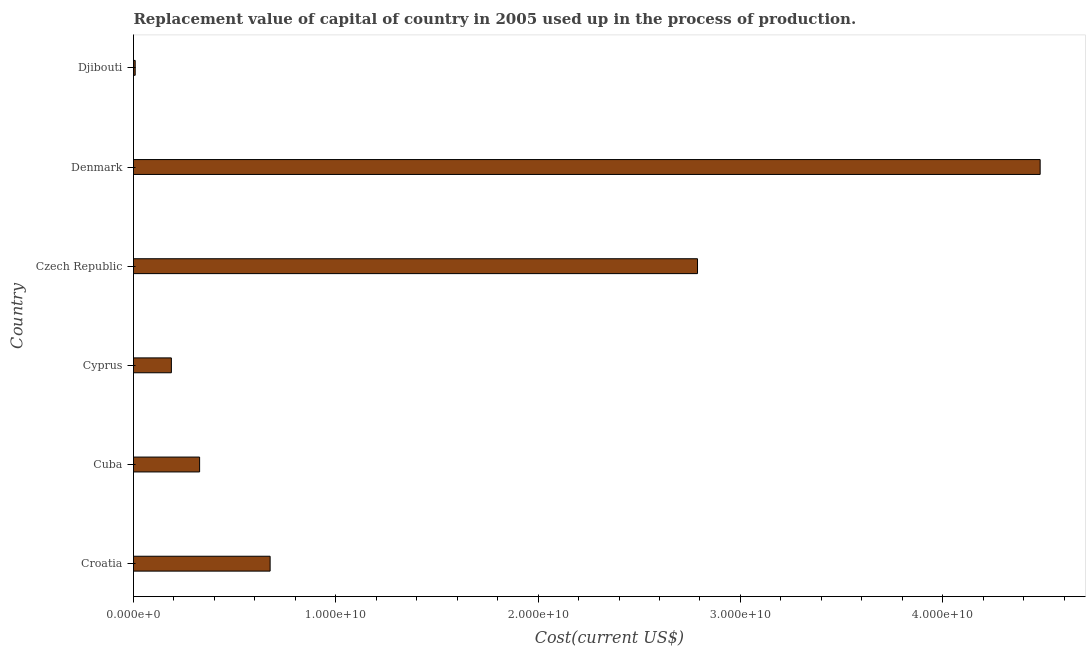What is the title of the graph?
Offer a very short reply. Replacement value of capital of country in 2005 used up in the process of production. What is the label or title of the X-axis?
Make the answer very short. Cost(current US$). What is the label or title of the Y-axis?
Provide a short and direct response. Country. What is the consumption of fixed capital in Denmark?
Ensure brevity in your answer.  4.48e+1. Across all countries, what is the maximum consumption of fixed capital?
Offer a very short reply. 4.48e+1. Across all countries, what is the minimum consumption of fixed capital?
Provide a short and direct response. 8.33e+07. In which country was the consumption of fixed capital minimum?
Give a very brief answer. Djibouti. What is the sum of the consumption of fixed capital?
Provide a succinct answer. 8.47e+1. What is the difference between the consumption of fixed capital in Cuba and Djibouti?
Provide a short and direct response. 3.18e+09. What is the average consumption of fixed capital per country?
Keep it short and to the point. 1.41e+1. What is the median consumption of fixed capital?
Ensure brevity in your answer.  5.01e+09. In how many countries, is the consumption of fixed capital greater than 44000000000 US$?
Your answer should be compact. 1. What is the ratio of the consumption of fixed capital in Cuba to that in Czech Republic?
Ensure brevity in your answer.  0.12. What is the difference between the highest and the second highest consumption of fixed capital?
Provide a succinct answer. 1.69e+1. Is the sum of the consumption of fixed capital in Denmark and Djibouti greater than the maximum consumption of fixed capital across all countries?
Your answer should be very brief. Yes. What is the difference between the highest and the lowest consumption of fixed capital?
Ensure brevity in your answer.  4.47e+1. In how many countries, is the consumption of fixed capital greater than the average consumption of fixed capital taken over all countries?
Provide a succinct answer. 2. How many bars are there?
Your response must be concise. 6. How many countries are there in the graph?
Offer a terse response. 6. Are the values on the major ticks of X-axis written in scientific E-notation?
Provide a short and direct response. Yes. What is the Cost(current US$) of Croatia?
Ensure brevity in your answer.  6.75e+09. What is the Cost(current US$) in Cuba?
Provide a short and direct response. 3.27e+09. What is the Cost(current US$) of Cyprus?
Your answer should be compact. 1.87e+09. What is the Cost(current US$) of Czech Republic?
Keep it short and to the point. 2.79e+1. What is the Cost(current US$) in Denmark?
Your answer should be very brief. 4.48e+1. What is the Cost(current US$) in Djibouti?
Provide a succinct answer. 8.33e+07. What is the difference between the Cost(current US$) in Croatia and Cuba?
Provide a succinct answer. 3.49e+09. What is the difference between the Cost(current US$) in Croatia and Cyprus?
Provide a succinct answer. 4.88e+09. What is the difference between the Cost(current US$) in Croatia and Czech Republic?
Your answer should be compact. -2.11e+1. What is the difference between the Cost(current US$) in Croatia and Denmark?
Your answer should be compact. -3.81e+1. What is the difference between the Cost(current US$) in Croatia and Djibouti?
Your answer should be very brief. 6.67e+09. What is the difference between the Cost(current US$) in Cuba and Cyprus?
Your response must be concise. 1.40e+09. What is the difference between the Cost(current US$) in Cuba and Czech Republic?
Provide a succinct answer. -2.46e+1. What is the difference between the Cost(current US$) in Cuba and Denmark?
Offer a very short reply. -4.15e+1. What is the difference between the Cost(current US$) in Cuba and Djibouti?
Provide a succinct answer. 3.18e+09. What is the difference between the Cost(current US$) in Cyprus and Czech Republic?
Provide a short and direct response. -2.60e+1. What is the difference between the Cost(current US$) in Cyprus and Denmark?
Your response must be concise. -4.29e+1. What is the difference between the Cost(current US$) in Cyprus and Djibouti?
Keep it short and to the point. 1.79e+09. What is the difference between the Cost(current US$) in Czech Republic and Denmark?
Offer a terse response. -1.69e+1. What is the difference between the Cost(current US$) in Czech Republic and Djibouti?
Make the answer very short. 2.78e+1. What is the difference between the Cost(current US$) in Denmark and Djibouti?
Give a very brief answer. 4.47e+1. What is the ratio of the Cost(current US$) in Croatia to that in Cuba?
Offer a terse response. 2.07. What is the ratio of the Cost(current US$) in Croatia to that in Cyprus?
Provide a succinct answer. 3.61. What is the ratio of the Cost(current US$) in Croatia to that in Czech Republic?
Make the answer very short. 0.24. What is the ratio of the Cost(current US$) in Croatia to that in Denmark?
Keep it short and to the point. 0.15. What is the ratio of the Cost(current US$) in Croatia to that in Djibouti?
Ensure brevity in your answer.  81.03. What is the ratio of the Cost(current US$) in Cuba to that in Cyprus?
Ensure brevity in your answer.  1.75. What is the ratio of the Cost(current US$) in Cuba to that in Czech Republic?
Provide a short and direct response. 0.12. What is the ratio of the Cost(current US$) in Cuba to that in Denmark?
Provide a short and direct response. 0.07. What is the ratio of the Cost(current US$) in Cuba to that in Djibouti?
Offer a very short reply. 39.2. What is the ratio of the Cost(current US$) in Cyprus to that in Czech Republic?
Provide a succinct answer. 0.07. What is the ratio of the Cost(current US$) in Cyprus to that in Denmark?
Your response must be concise. 0.04. What is the ratio of the Cost(current US$) in Cyprus to that in Djibouti?
Provide a succinct answer. 22.46. What is the ratio of the Cost(current US$) in Czech Republic to that in Denmark?
Keep it short and to the point. 0.62. What is the ratio of the Cost(current US$) in Czech Republic to that in Djibouti?
Provide a succinct answer. 334.52. What is the ratio of the Cost(current US$) in Denmark to that in Djibouti?
Offer a terse response. 537.75. 